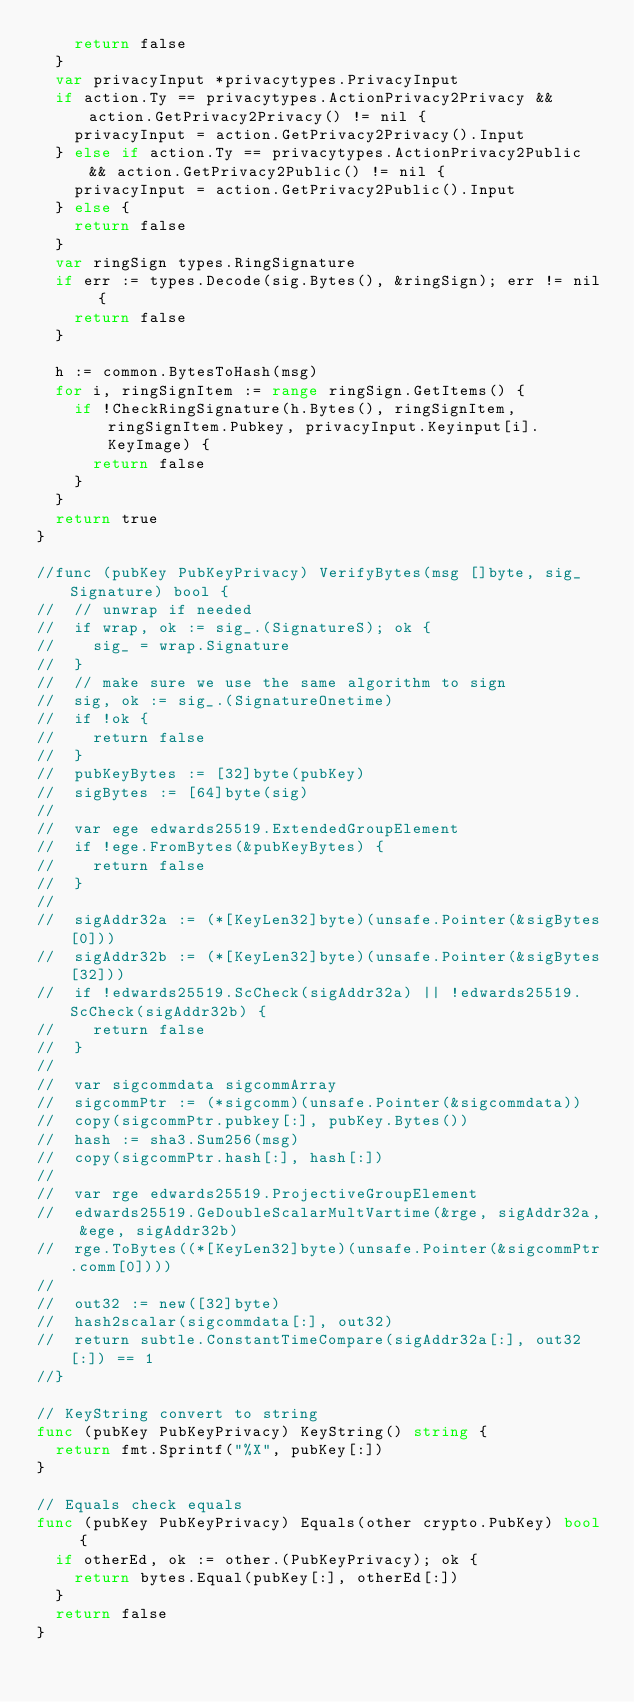Convert code to text. <code><loc_0><loc_0><loc_500><loc_500><_Go_>		return false
	}
	var privacyInput *privacytypes.PrivacyInput
	if action.Ty == privacytypes.ActionPrivacy2Privacy && action.GetPrivacy2Privacy() != nil {
		privacyInput = action.GetPrivacy2Privacy().Input
	} else if action.Ty == privacytypes.ActionPrivacy2Public && action.GetPrivacy2Public() != nil {
		privacyInput = action.GetPrivacy2Public().Input
	} else {
		return false
	}
	var ringSign types.RingSignature
	if err := types.Decode(sig.Bytes(), &ringSign); err != nil {
		return false
	}

	h := common.BytesToHash(msg)
	for i, ringSignItem := range ringSign.GetItems() {
		if !CheckRingSignature(h.Bytes(), ringSignItem, ringSignItem.Pubkey, privacyInput.Keyinput[i].KeyImage) {
			return false
		}
	}
	return true
}

//func (pubKey PubKeyPrivacy) VerifyBytes(msg []byte, sig_ Signature) bool {
//	// unwrap if needed
//	if wrap, ok := sig_.(SignatureS); ok {
//		sig_ = wrap.Signature
//	}
//	// make sure we use the same algorithm to sign
//	sig, ok := sig_.(SignatureOnetime)
//	if !ok {
//		return false
//	}
//	pubKeyBytes := [32]byte(pubKey)
//	sigBytes := [64]byte(sig)
//
//	var ege edwards25519.ExtendedGroupElement
//	if !ege.FromBytes(&pubKeyBytes) {
//		return false
//	}
//
//	sigAddr32a := (*[KeyLen32]byte)(unsafe.Pointer(&sigBytes[0]))
//	sigAddr32b := (*[KeyLen32]byte)(unsafe.Pointer(&sigBytes[32]))
//	if !edwards25519.ScCheck(sigAddr32a) || !edwards25519.ScCheck(sigAddr32b) {
//		return false
//	}
//
//	var sigcommdata sigcommArray
//	sigcommPtr := (*sigcomm)(unsafe.Pointer(&sigcommdata))
//	copy(sigcommPtr.pubkey[:], pubKey.Bytes())
//	hash := sha3.Sum256(msg)
//	copy(sigcommPtr.hash[:], hash[:])
//
//	var rge edwards25519.ProjectiveGroupElement
//	edwards25519.GeDoubleScalarMultVartime(&rge, sigAddr32a, &ege, sigAddr32b)
//	rge.ToBytes((*[KeyLen32]byte)(unsafe.Pointer(&sigcommPtr.comm[0])))
//
//	out32 := new([32]byte)
//	hash2scalar(sigcommdata[:], out32)
//	return subtle.ConstantTimeCompare(sigAddr32a[:], out32[:]) == 1
//}

// KeyString convert to string
func (pubKey PubKeyPrivacy) KeyString() string {
	return fmt.Sprintf("%X", pubKey[:])
}

// Equals check equals
func (pubKey PubKeyPrivacy) Equals(other crypto.PubKey) bool {
	if otherEd, ok := other.(PubKeyPrivacy); ok {
		return bytes.Equal(pubKey[:], otherEd[:])
	}
	return false
}
</code> 